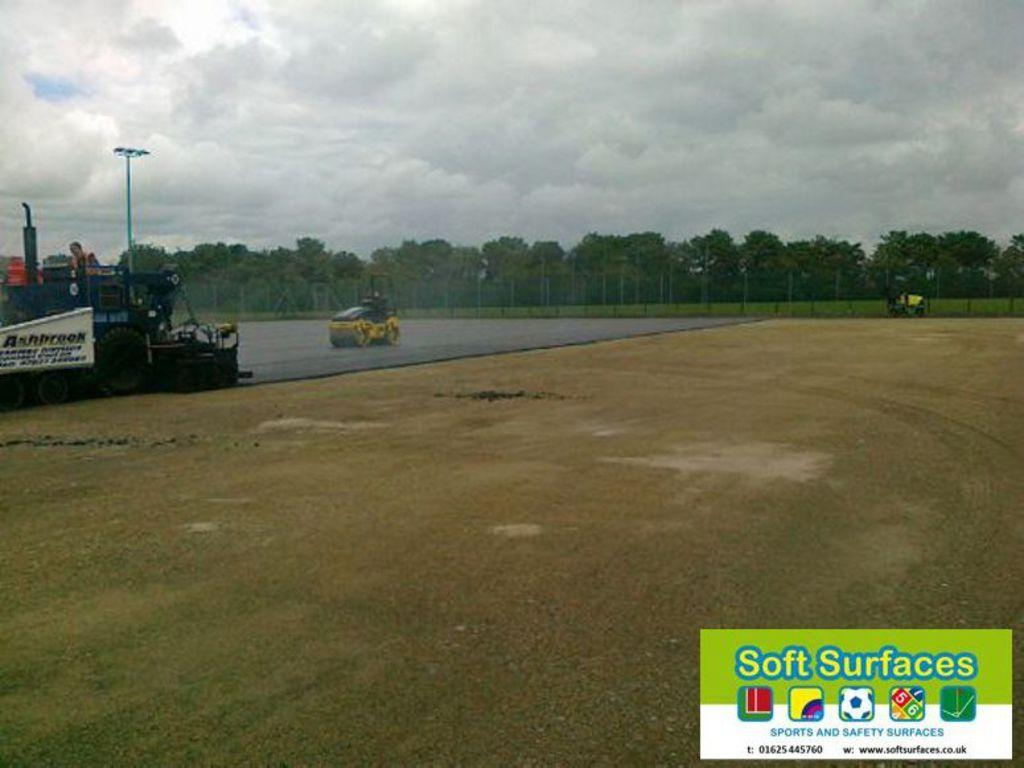How many vehicles are on the road in the image? There are two vehicles on the road in the image. What can be seen in the background of the image? In the background, there is a fence, an object, a pole, trees, and grass. What is visible in the sky in the image? There are clouds in the sky in the image. What type of quartz can be seen in the image? There is no quartz present in the image. What kind of haircut does the laborer have in the image? There is no laborer or haircut present in the image. 